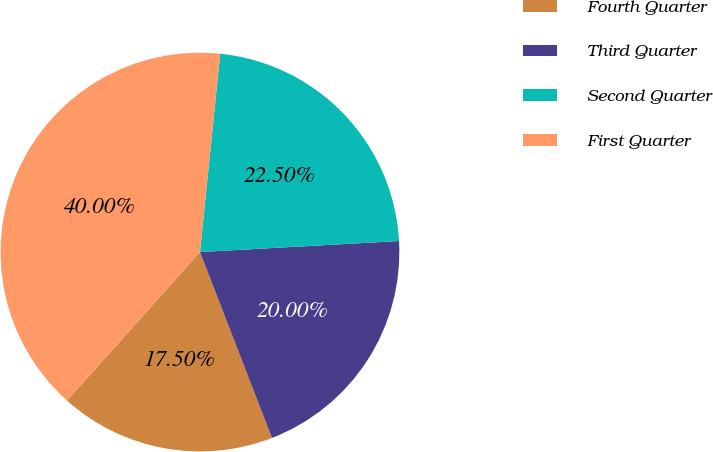Convert chart. <chart><loc_0><loc_0><loc_500><loc_500><pie_chart><fcel>Fourth Quarter<fcel>Third Quarter<fcel>Second Quarter<fcel>First Quarter<nl><fcel>17.5%<fcel>20.0%<fcel>22.5%<fcel>40.0%<nl></chart> 